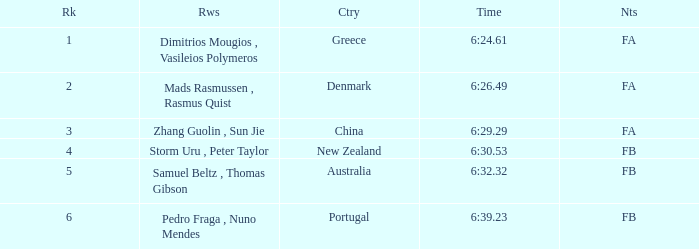What is the rank of the time of 6:30.53? 1.0. 